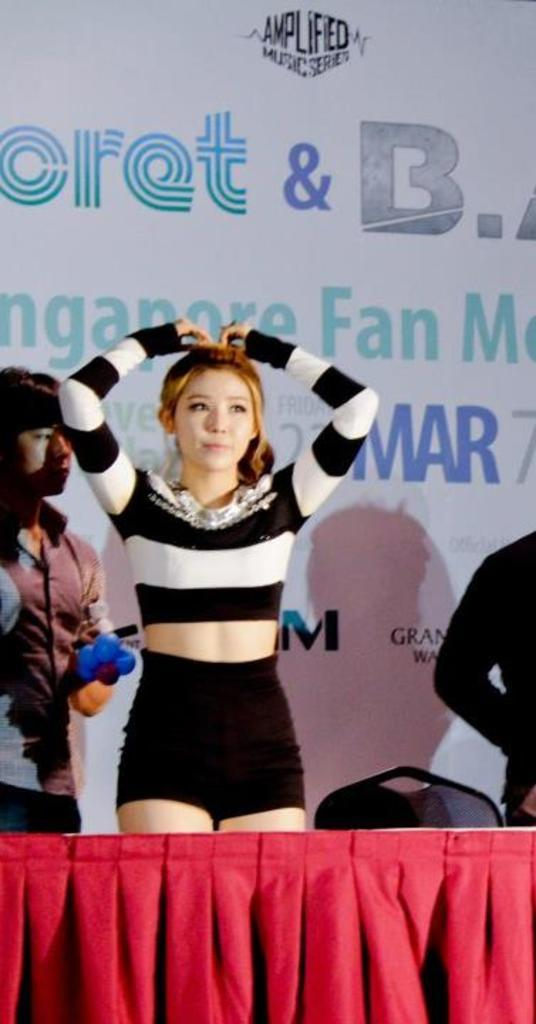Provide a one-sentence caption for the provided image. A women resting her hands on her head in front of a sign for a fan meeting. 